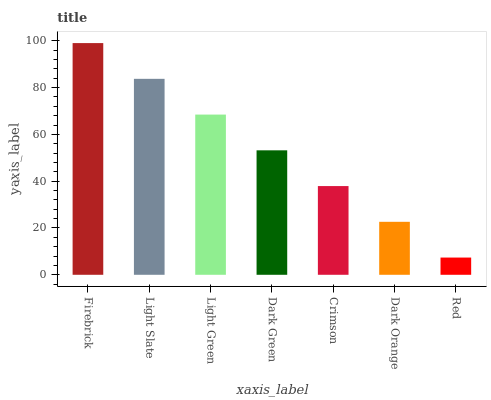Is Red the minimum?
Answer yes or no. Yes. Is Firebrick the maximum?
Answer yes or no. Yes. Is Light Slate the minimum?
Answer yes or no. No. Is Light Slate the maximum?
Answer yes or no. No. Is Firebrick greater than Light Slate?
Answer yes or no. Yes. Is Light Slate less than Firebrick?
Answer yes or no. Yes. Is Light Slate greater than Firebrick?
Answer yes or no. No. Is Firebrick less than Light Slate?
Answer yes or no. No. Is Dark Green the high median?
Answer yes or no. Yes. Is Dark Green the low median?
Answer yes or no. Yes. Is Red the high median?
Answer yes or no. No. Is Red the low median?
Answer yes or no. No. 